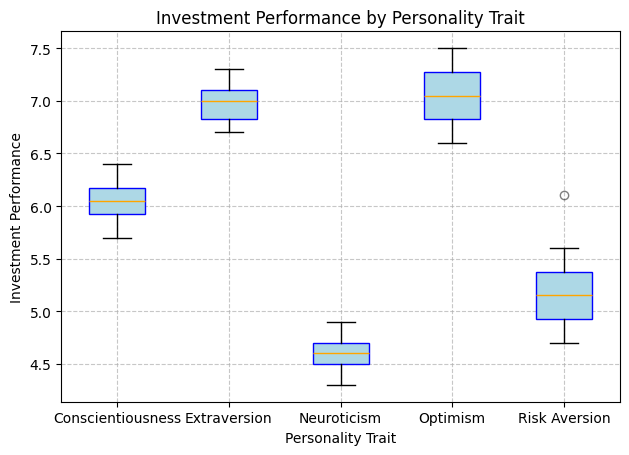What is the median investment performance for individuals with optimism? The boxplot shows the median line for each personality trait group. For optimism, locate the central line within the box to determine the median.
Answer: 7.0 Which personality trait shows the lowest median investment performance? Compare the median lines of all personality traits on the boxplot. The lowest median line identifies the group with the lowest median investment performance.
Answer: Neuroticism What is the interquartile range (IQR) for the investment performance of individuals with conscientiousness? The IQR is calculated by subtracting the value of the lower quartile (Q1) from the upper quartile (Q3). Identify Q1 and Q3 by examining the boundaries of the box for conscientiousness and calculate the difference.
Answer: 0.6 Which two personality traits have the most similar median investment performance? Evaluate the median lines for all personality traits and find the two that are closest in value.
Answer: Extraversion and Optimism Between risk aversion and neuroticism, which group has a higher maximum investment performance? Identify the top whisker locations for both risk aversion and neuroticism, representing their maximum values, and compare these two values.
Answer: Risk Aversion What is the range of investment performance for individuals with extraversion? The range is calculated by subtracting the minimum value from the maximum value. Locate the bottom and top whiskers for extraversion to find these values and perform the subtraction.
Answer: 0.6 Identify the personality trait with the largest spread in investment performance. The spread (or variability) within a group is indicated by the length of the whiskers plus the size of the box. Compare the total lengths for all personality traits to find the largest spread.
Answer: Risk Aversion Which personality trait shows the least variability in investment performance? The least variability is indicated by the shortest combined length of the whiskers and the box. Compare all the groups' whiskers and box sizes to find the smallest combined length.
Answer: Optimism How does the median investment performance for conscientiousness compare to the median for extraversion? By examining the central lines within the boxes for conscientiousness and extraversion, compare their heights directly to see which is higher.
Answer: Lower 